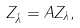<formula> <loc_0><loc_0><loc_500><loc_500>Z _ { \bar { \lambda } } = A Z _ { \lambda } ,</formula> 